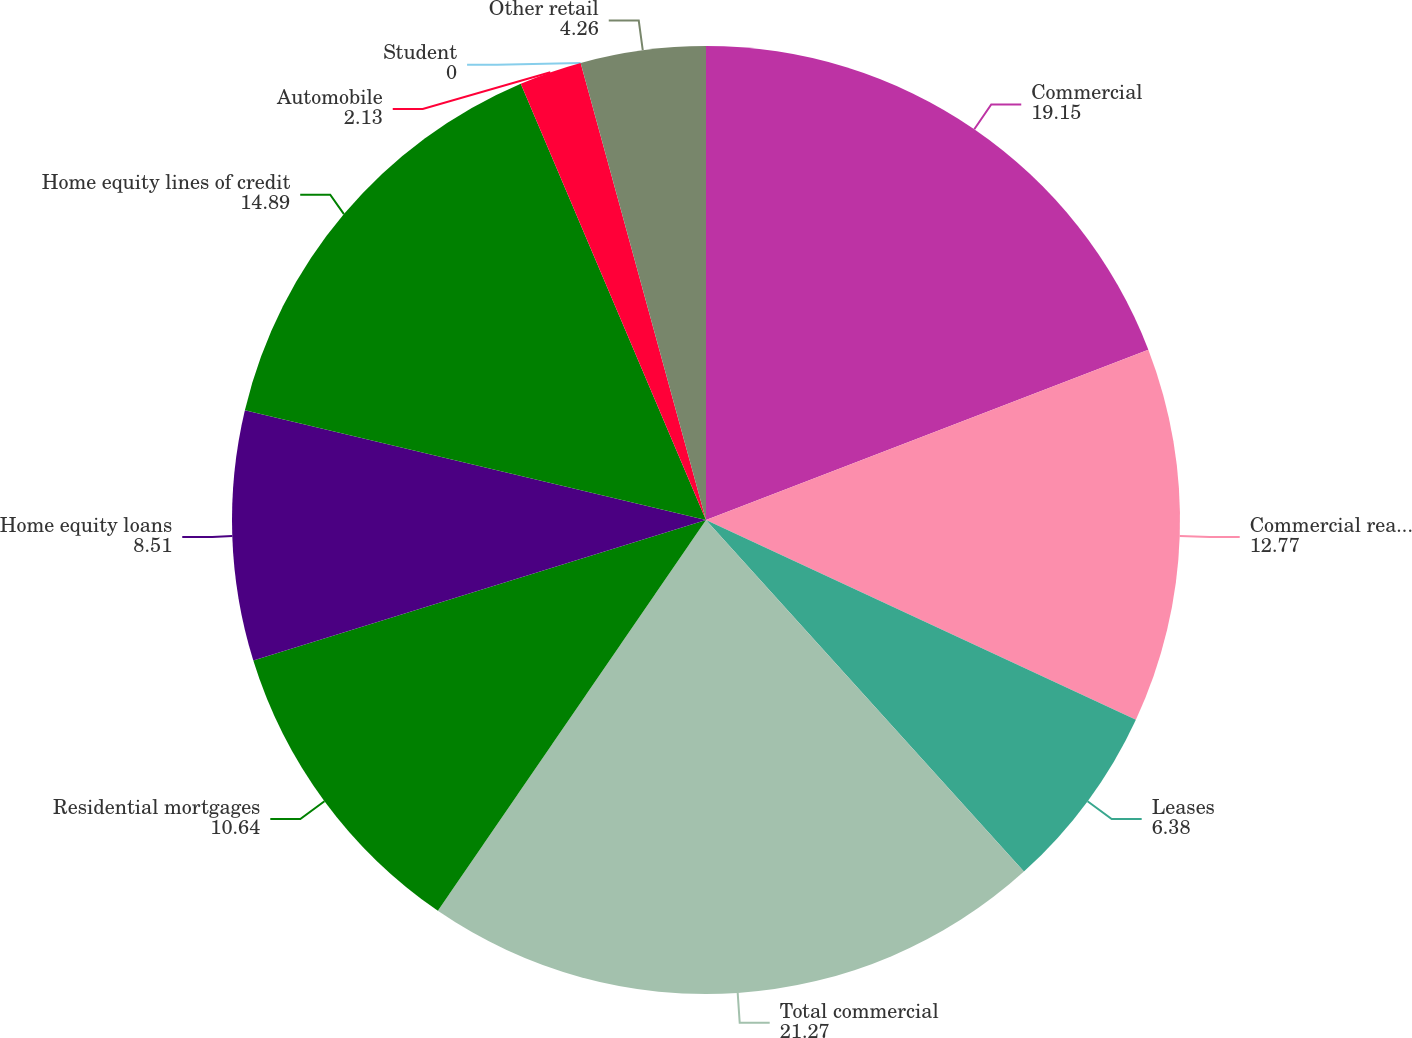<chart> <loc_0><loc_0><loc_500><loc_500><pie_chart><fcel>Commercial<fcel>Commercial real estate<fcel>Leases<fcel>Total commercial<fcel>Residential mortgages<fcel>Home equity loans<fcel>Home equity lines of credit<fcel>Automobile<fcel>Student<fcel>Other retail<nl><fcel>19.15%<fcel>12.77%<fcel>6.38%<fcel>21.27%<fcel>10.64%<fcel>8.51%<fcel>14.89%<fcel>2.13%<fcel>0.0%<fcel>4.26%<nl></chart> 